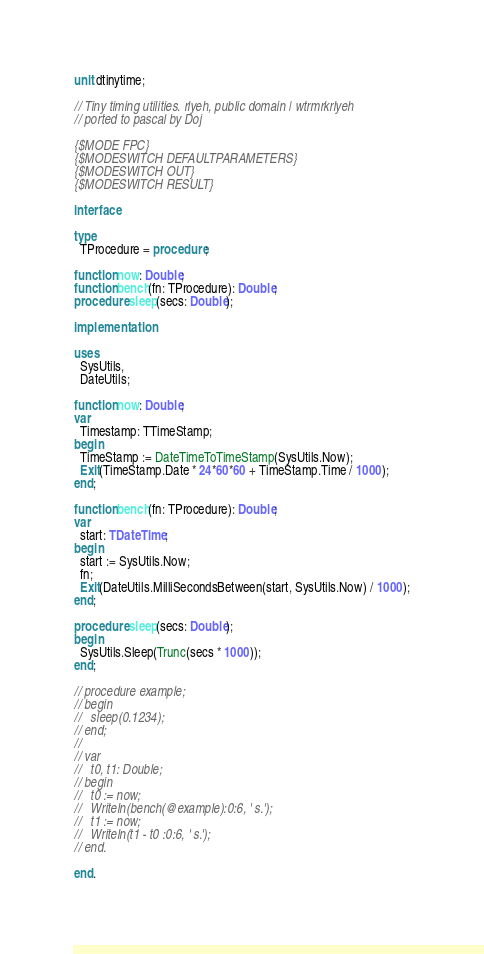Convert code to text. <code><loc_0><loc_0><loc_500><loc_500><_Pascal_>unit dtinytime;

// Tiny timing utilities. rlyeh, public domain | wtrmrkrlyeh
// ported to pascal by Doj

{$MODE FPC}
{$MODESWITCH DEFAULTPARAMETERS}
{$MODESWITCH OUT}
{$MODESWITCH RESULT}

interface

type
  TProcedure = procedure;

function now: Double;
function bench(fn: TProcedure): Double;
procedure sleep(secs: Double);

implementation

uses
  SysUtils,
  DateUtils;

function now: Double;
var
  Timestamp: TTimeStamp;
begin
  TimeStamp := DateTimeToTimeStamp(SysUtils.Now);
  Exit(TimeStamp.Date * 24*60*60 + TimeStamp.Time / 1000);
end;

function bench(fn: TProcedure): Double;
var
  start: TDateTime;
begin
  start := SysUtils.Now;
  fn;
  Exit(DateUtils.MilliSecondsBetween(start, SysUtils.Now) / 1000);
end;

procedure sleep(secs: Double);
begin
  SysUtils.Sleep(Trunc(secs * 1000));
end;

// procedure example;
// begin
//   sleep(0.1234);
// end;
//
// var
//   t0, t1: Double;
// begin
//   t0 := now;
//   Writeln(bench(@example):0:6, ' s.');
//   t1 := now;
//   Writeln(t1 - t0 :0:6, ' s.');
// end.

end.
</code> 